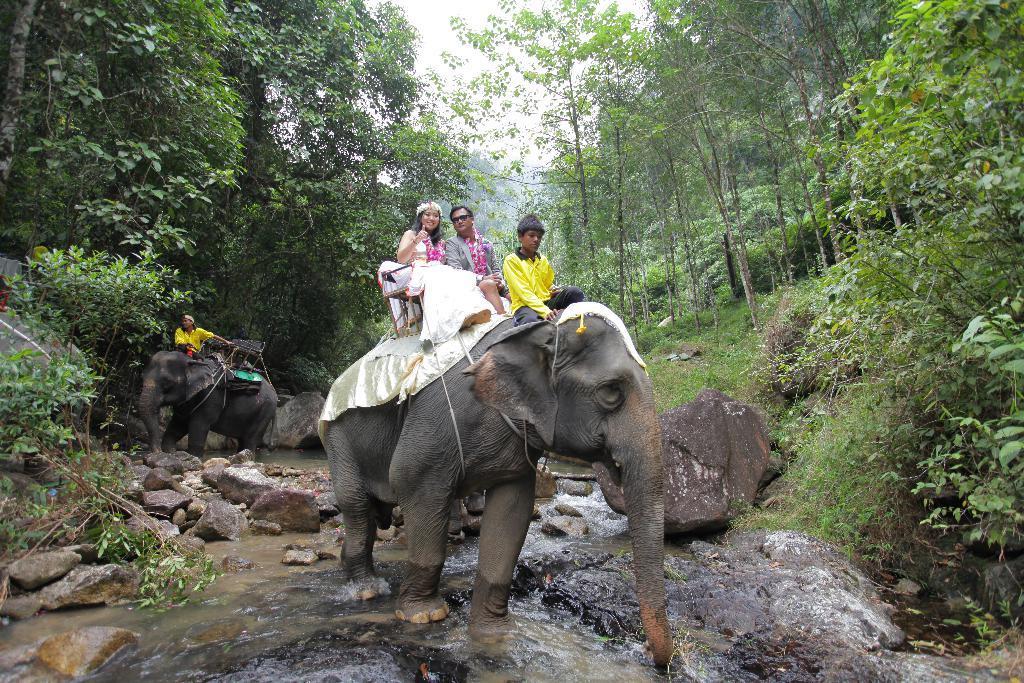Can you describe this image briefly? In this image i can see a group of people who are riding on elephant. Here we have two elephants who are walking in the water, we also see there are few trees and plants on the ground. 